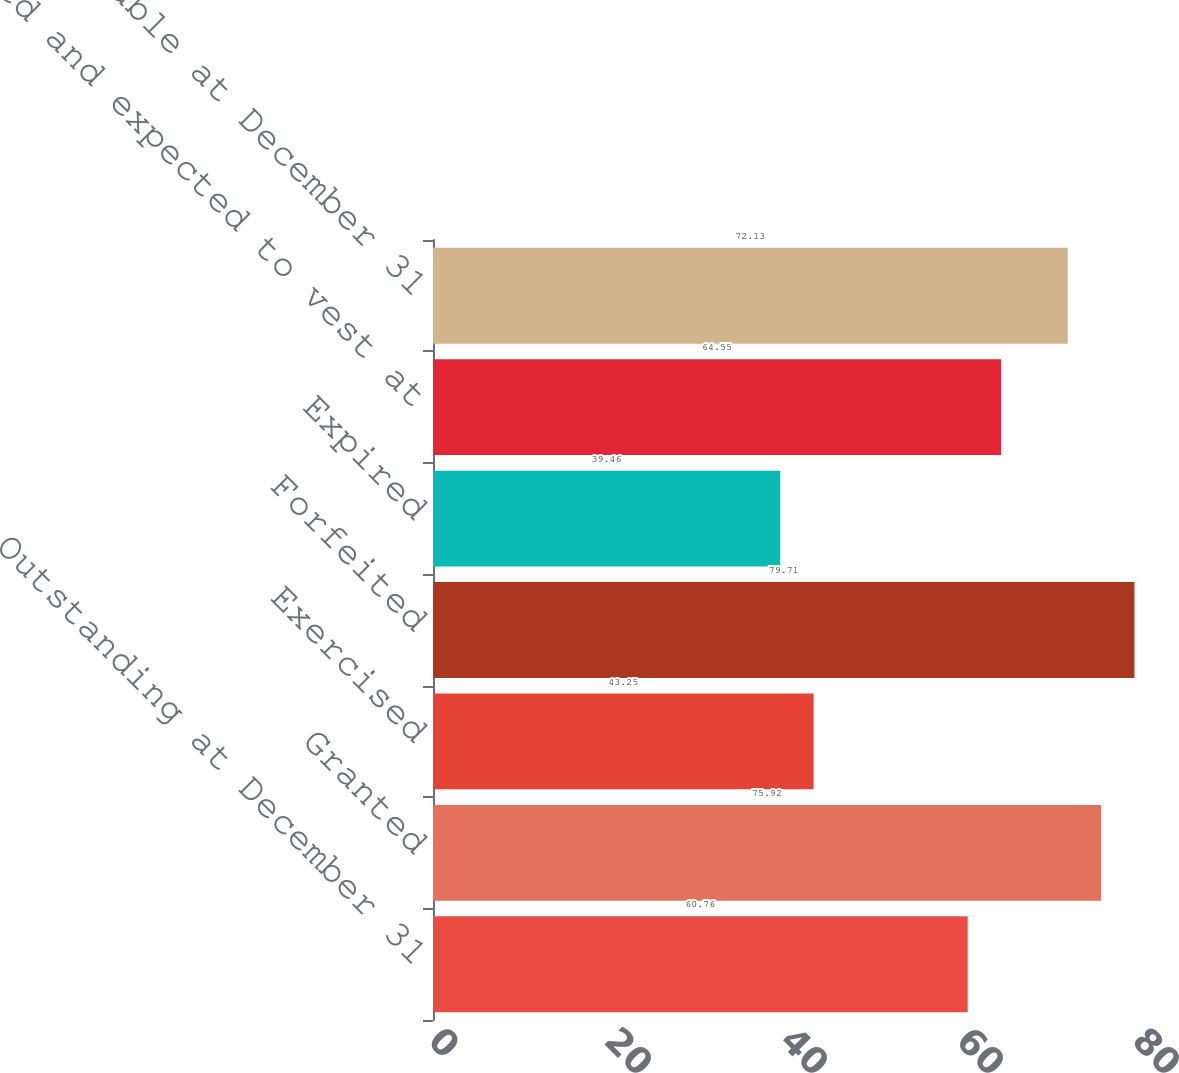Convert chart. <chart><loc_0><loc_0><loc_500><loc_500><bar_chart><fcel>Outstanding at December 31<fcel>Granted<fcel>Exercised<fcel>Forfeited<fcel>Expired<fcel>Vested and expected to vest at<fcel>Exercisable at December 31<nl><fcel>60.76<fcel>75.92<fcel>43.25<fcel>79.71<fcel>39.46<fcel>64.55<fcel>72.13<nl></chart> 